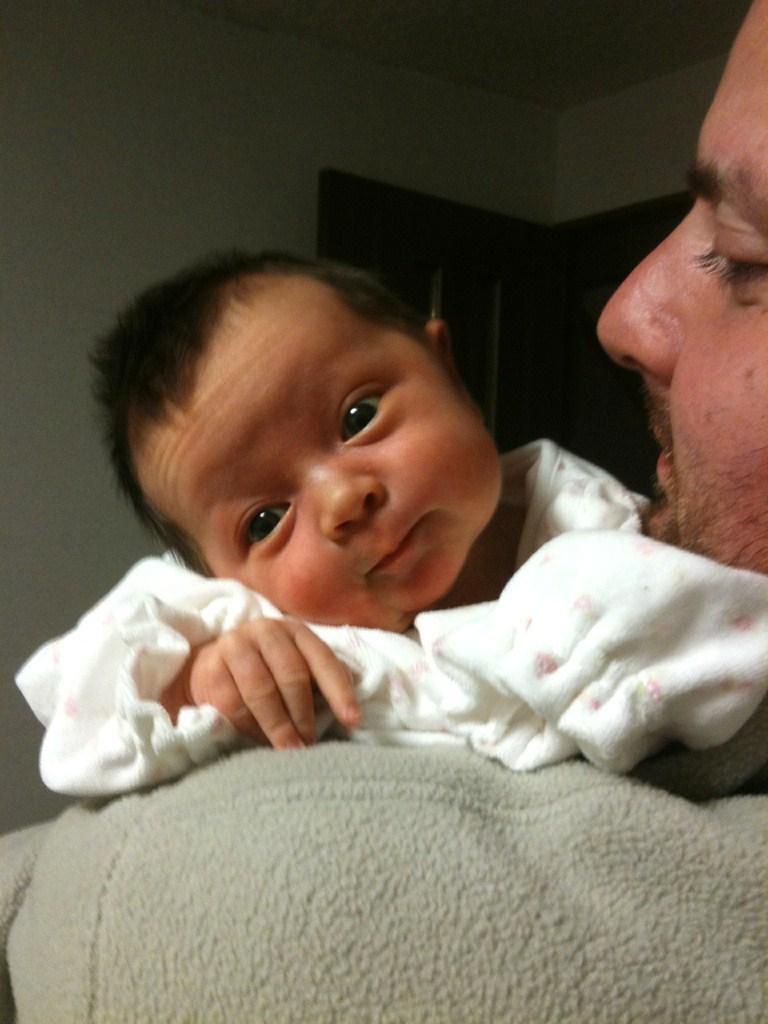Can you describe this image briefly? This image consists of a man holding a small kid. The kid is wearing white dress. The man is wearing gray sweater. In the background, there is a wall along with a door. 